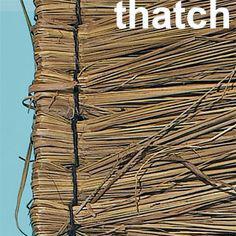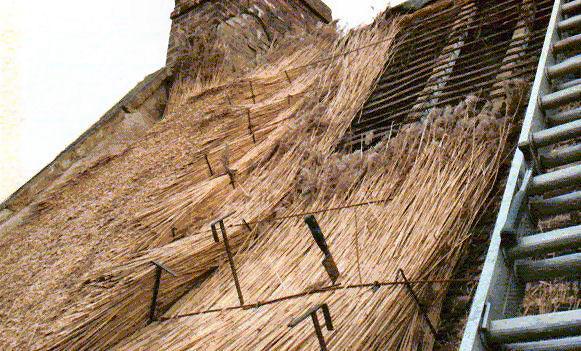The first image is the image on the left, the second image is the image on the right. Assess this claim about the two images: "The left image is just of a sample of hatch, no parts of a house can be seen.". Correct or not? Answer yes or no. Yes. 